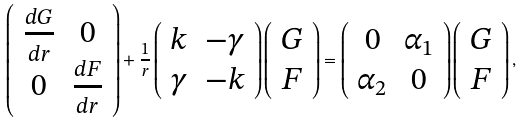Convert formula to latex. <formula><loc_0><loc_0><loc_500><loc_500>\left ( \begin{array} { c c } \frac { d G } { d r } & 0 \\ 0 & \frac { d F } { d r } \end{array} \right ) + \frac { 1 } { r } \left ( \begin{array} { c c } k & - \gamma \\ \gamma & - k \end{array} \right ) \left ( \begin{array} { c } G \\ F \end{array} \right ) = \left ( \begin{array} { c c } 0 & \alpha _ { 1 } \\ \alpha _ { 2 } & 0 \end{array} \right ) \left ( \begin{array} { c } G \\ F \end{array} \right ) ,</formula> 